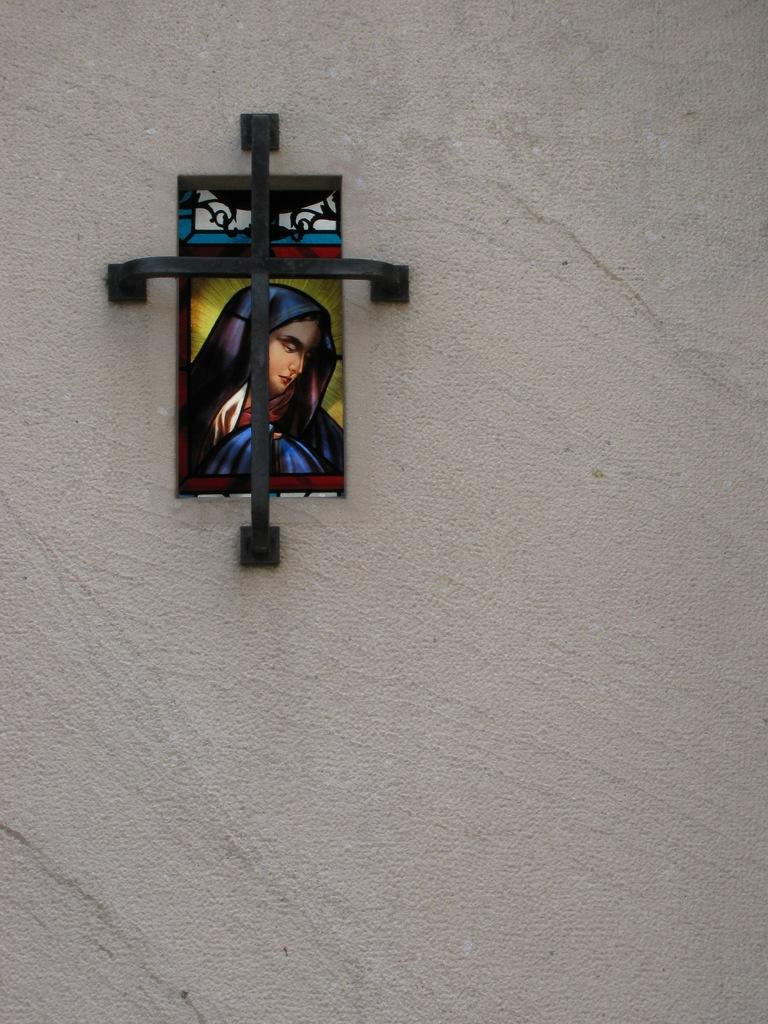What is attached to the wall in the image? There is a colorful board attached to the wall. What is the material of the object attached to the board? The board has a black color iron material attached to it. What color is the wall in the image? The wall is grey in color. Can you tell me how many plastic bags are lying in the alley in the image? There is no alley or plastic bags present in the image; it only features a colorful board with a black iron material attached to a grey wall. 